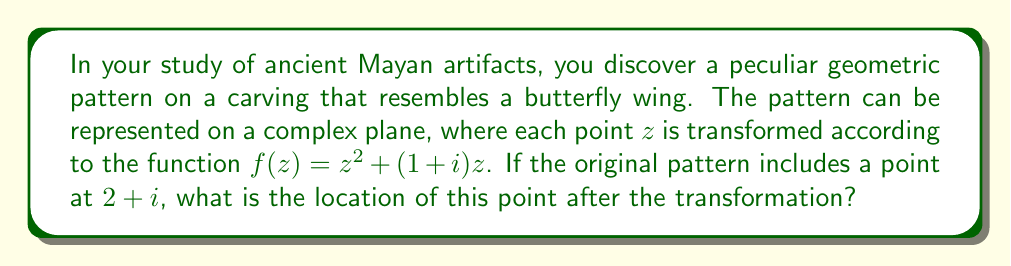Provide a solution to this math problem. Let's approach this step-by-step:

1) We are given the transformation function:
   $f(z) = z^2 + (1+i)z$

2) We need to find $f(2+i)$. So, let's substitute $z = 2+i$ into the function:
   $f(2+i) = (2+i)^2 + (1+i)(2+i)$

3) Let's evaluate the first term $(2+i)^2$:
   $(2+i)^2 = 4 + 4i + i^2 = 4 + 4i - 1 = 3 + 4i$

4) Now, let's evaluate the second term $(1+i)(2+i)$:
   $(1+i)(2+i) = 2 + 2i + i + i^2 = 2 + 2i + i - 1 = 1 + 3i$

5) Now we can add these results:
   $f(2+i) = (3 + 4i) + (1 + 3i) = 4 + 7i$

Therefore, the point $(2+i)$ is transformed to the point $(4+7i)$ on the complex plane.
Answer: $4+7i$ 